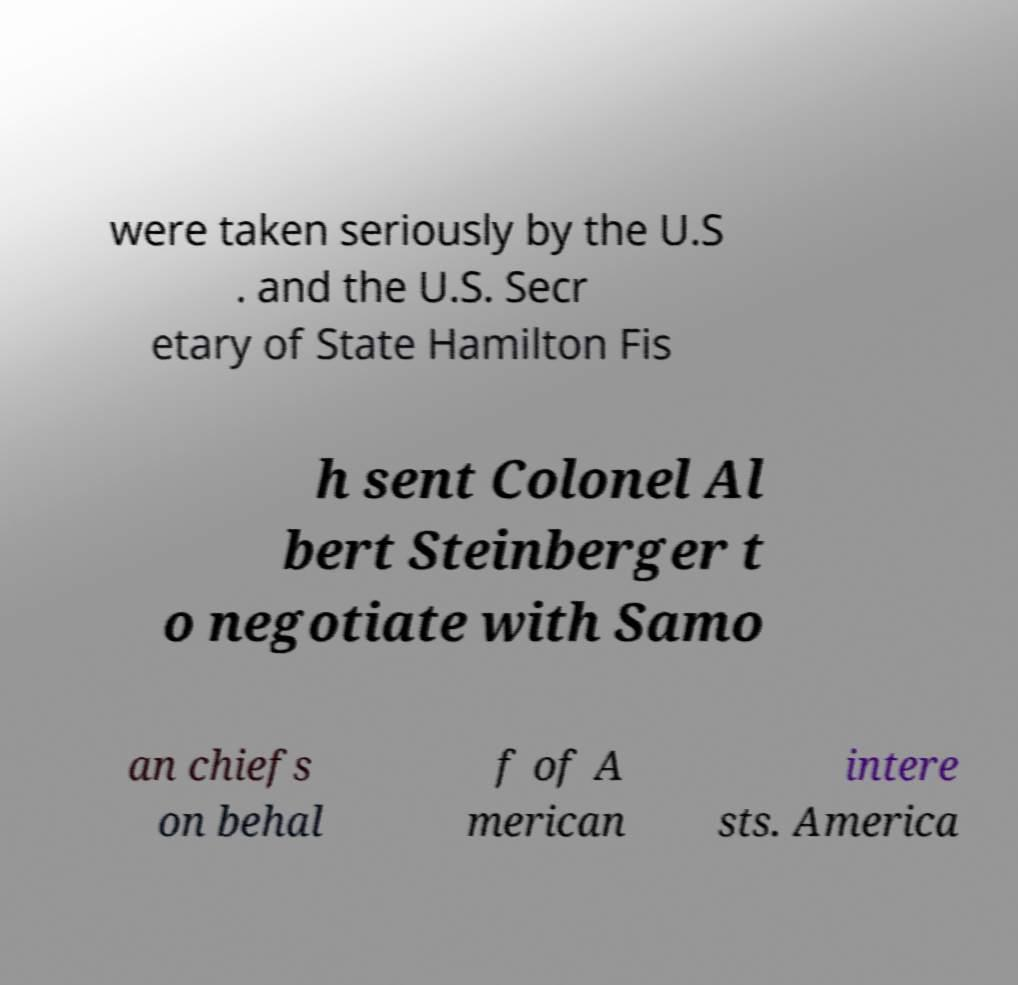Can you accurately transcribe the text from the provided image for me? were taken seriously by the U.S . and the U.S. Secr etary of State Hamilton Fis h sent Colonel Al bert Steinberger t o negotiate with Samo an chiefs on behal f of A merican intere sts. America 